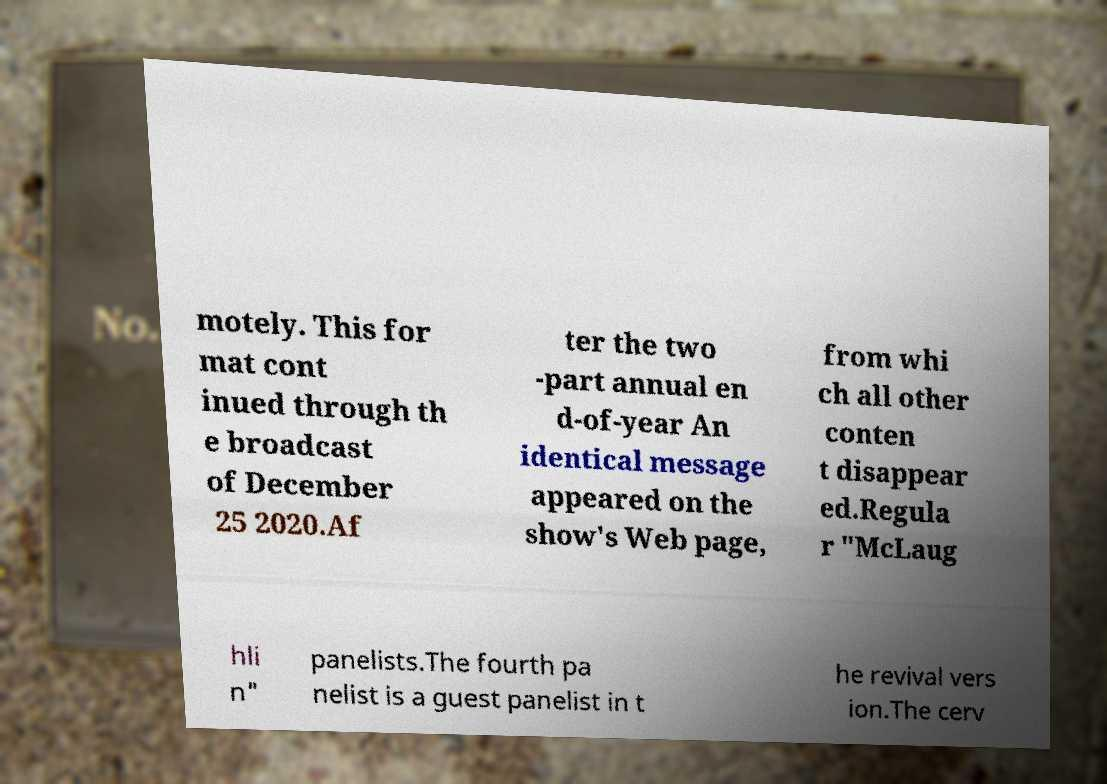I need the written content from this picture converted into text. Can you do that? motely. This for mat cont inued through th e broadcast of December 25 2020.Af ter the two -part annual en d-of-year An identical message appeared on the show's Web page, from whi ch all other conten t disappear ed.Regula r "McLaug hli n" panelists.The fourth pa nelist is a guest panelist in t he revival vers ion.The cerv 